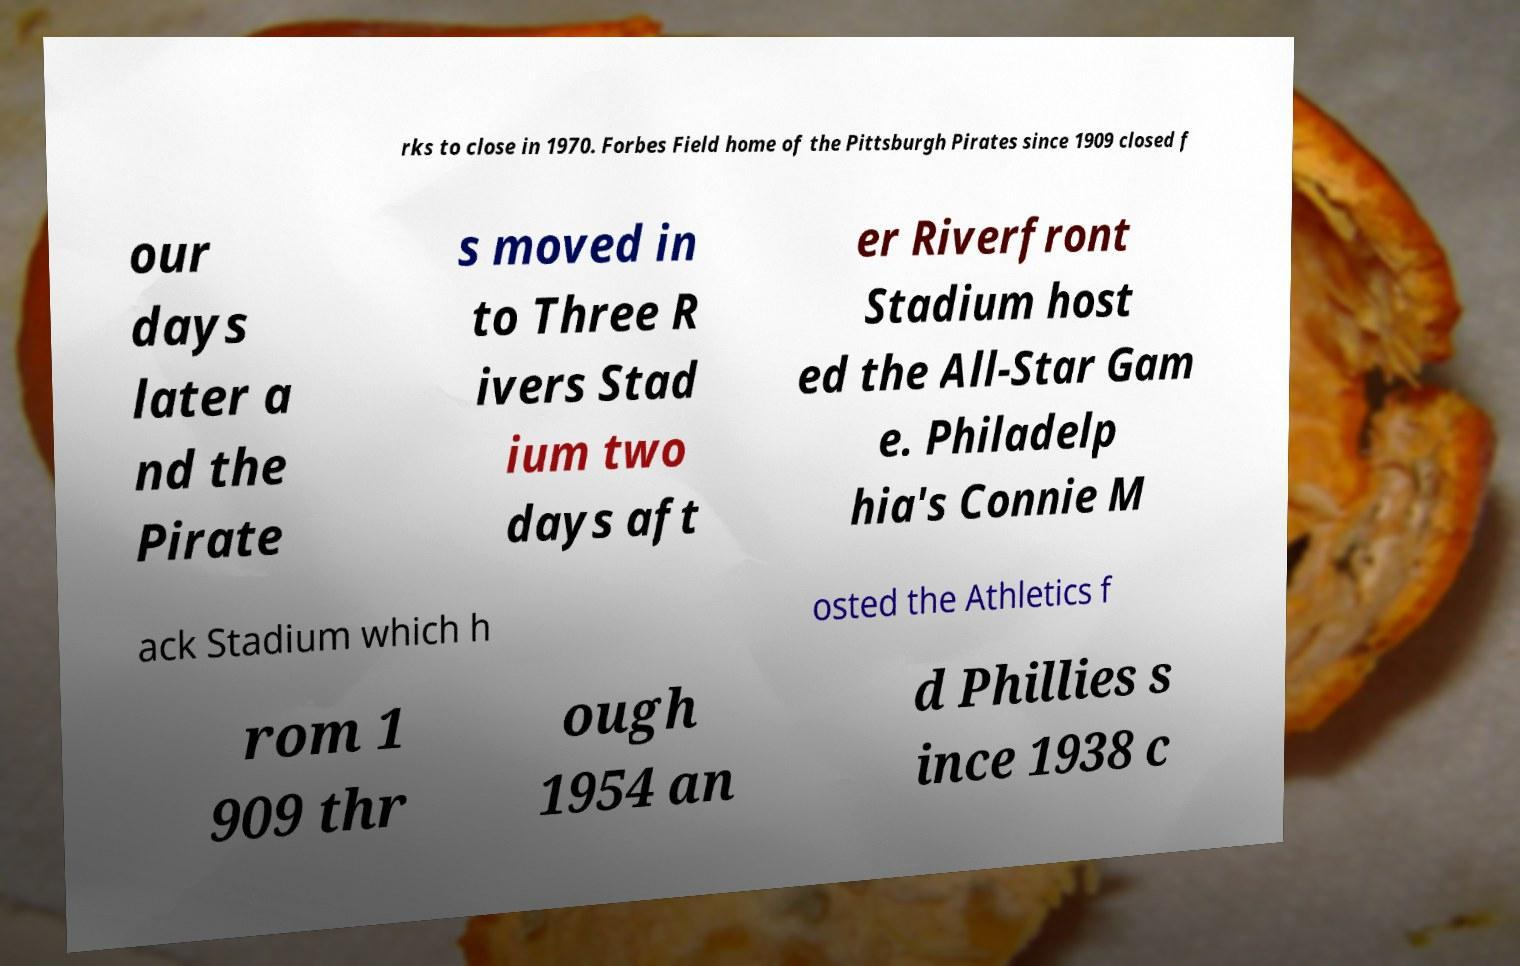What messages or text are displayed in this image? I need them in a readable, typed format. rks to close in 1970. Forbes Field home of the Pittsburgh Pirates since 1909 closed f our days later a nd the Pirate s moved in to Three R ivers Stad ium two days aft er Riverfront Stadium host ed the All-Star Gam e. Philadelp hia's Connie M ack Stadium which h osted the Athletics f rom 1 909 thr ough 1954 an d Phillies s ince 1938 c 